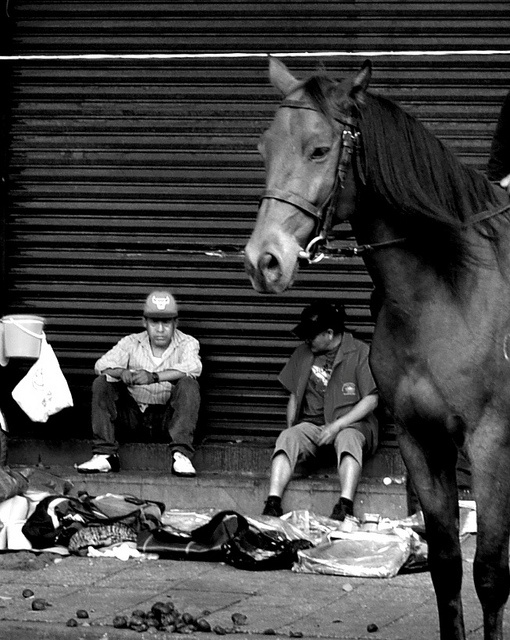Describe the objects in this image and their specific colors. I can see horse in black, gray, darkgray, and lightgray tones, people in black, gray, darkgray, and lightgray tones, and people in black, lightgray, gray, and darkgray tones in this image. 